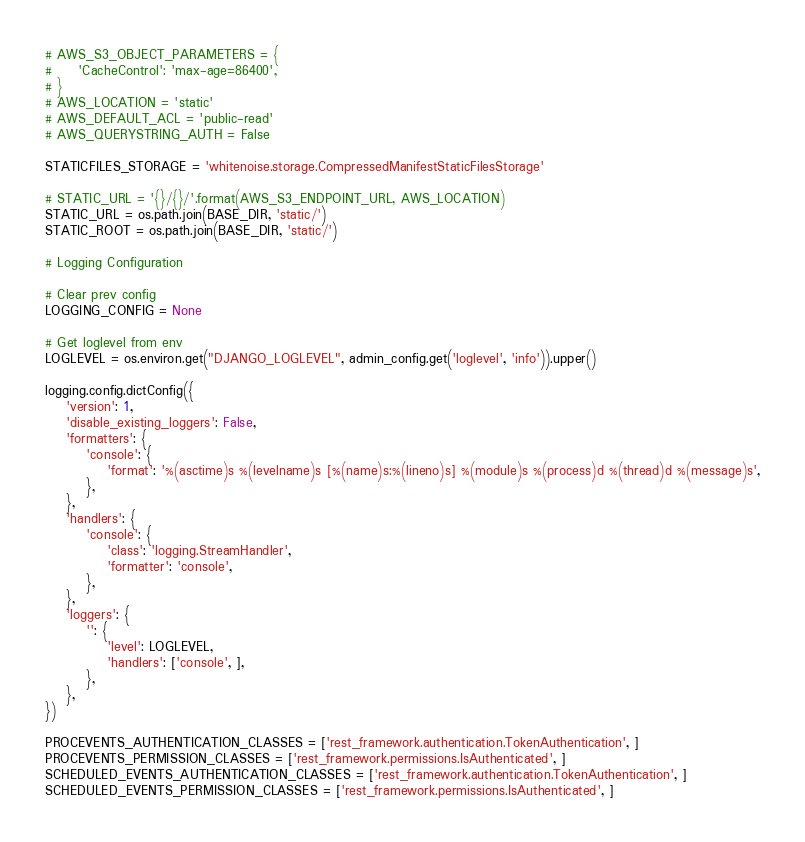Convert code to text. <code><loc_0><loc_0><loc_500><loc_500><_Python_># AWS_S3_OBJECT_PARAMETERS = {
#     'CacheControl': 'max-age=86400',
# }
# AWS_LOCATION = 'static'
# AWS_DEFAULT_ACL = 'public-read'
# AWS_QUERYSTRING_AUTH = False

STATICFILES_STORAGE = 'whitenoise.storage.CompressedManifestStaticFilesStorage'

# STATIC_URL = '{}/{}/'.format(AWS_S3_ENDPOINT_URL, AWS_LOCATION)
STATIC_URL = os.path.join(BASE_DIR, 'static/')
STATIC_ROOT = os.path.join(BASE_DIR, 'static/')

# Logging Configuration

# Clear prev config
LOGGING_CONFIG = None

# Get loglevel from env
LOGLEVEL = os.environ.get("DJANGO_LOGLEVEL", admin_config.get('loglevel', 'info')).upper()

logging.config.dictConfig({
    'version': 1,
    'disable_existing_loggers': False,
    'formatters': {
        'console': {
            'format': '%(asctime)s %(levelname)s [%(name)s:%(lineno)s] %(module)s %(process)d %(thread)d %(message)s',
        },
    },
    'handlers': {
        'console': {
            'class': 'logging.StreamHandler',
            'formatter': 'console',
        },
    },
    'loggers': {
        '': {
            'level': LOGLEVEL,
            'handlers': ['console', ],
        },
    },
})

PROCEVENTS_AUTHENTICATION_CLASSES = ['rest_framework.authentication.TokenAuthentication', ]
PROCEVENTS_PERMISSION_CLASSES = ['rest_framework.permissions.IsAuthenticated', ]
SCHEDULED_EVENTS_AUTHENTICATION_CLASSES = ['rest_framework.authentication.TokenAuthentication', ]
SCHEDULED_EVENTS_PERMISSION_CLASSES = ['rest_framework.permissions.IsAuthenticated', ]
</code> 